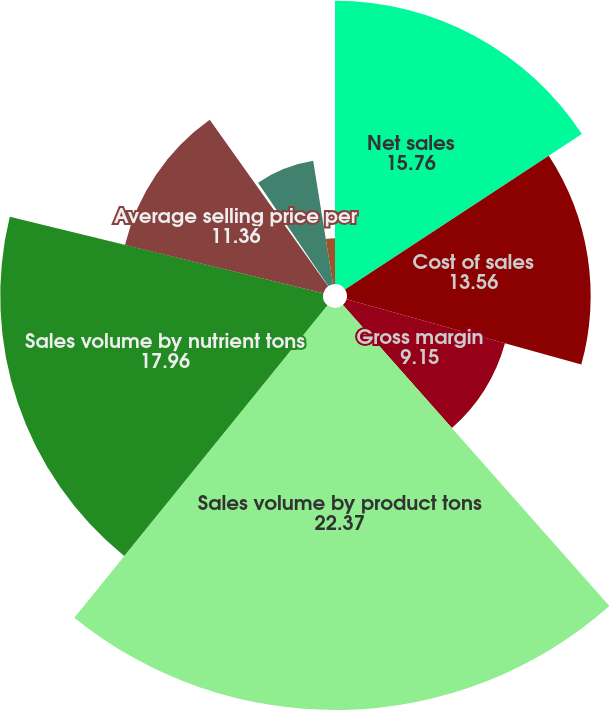Convert chart. <chart><loc_0><loc_0><loc_500><loc_500><pie_chart><fcel>Net sales<fcel>Cost of sales<fcel>Gross margin<fcel>Sales volume by product tons<fcel>Sales volume by nutrient tons<fcel>Average selling price per<fcel>Gross margin per product ton<fcel>Gross margin per nutrient ton<fcel>Depreciation and amortization<nl><fcel>15.76%<fcel>13.56%<fcel>9.15%<fcel>22.37%<fcel>17.96%<fcel>11.36%<fcel>0.34%<fcel>6.95%<fcel>2.55%<nl></chart> 